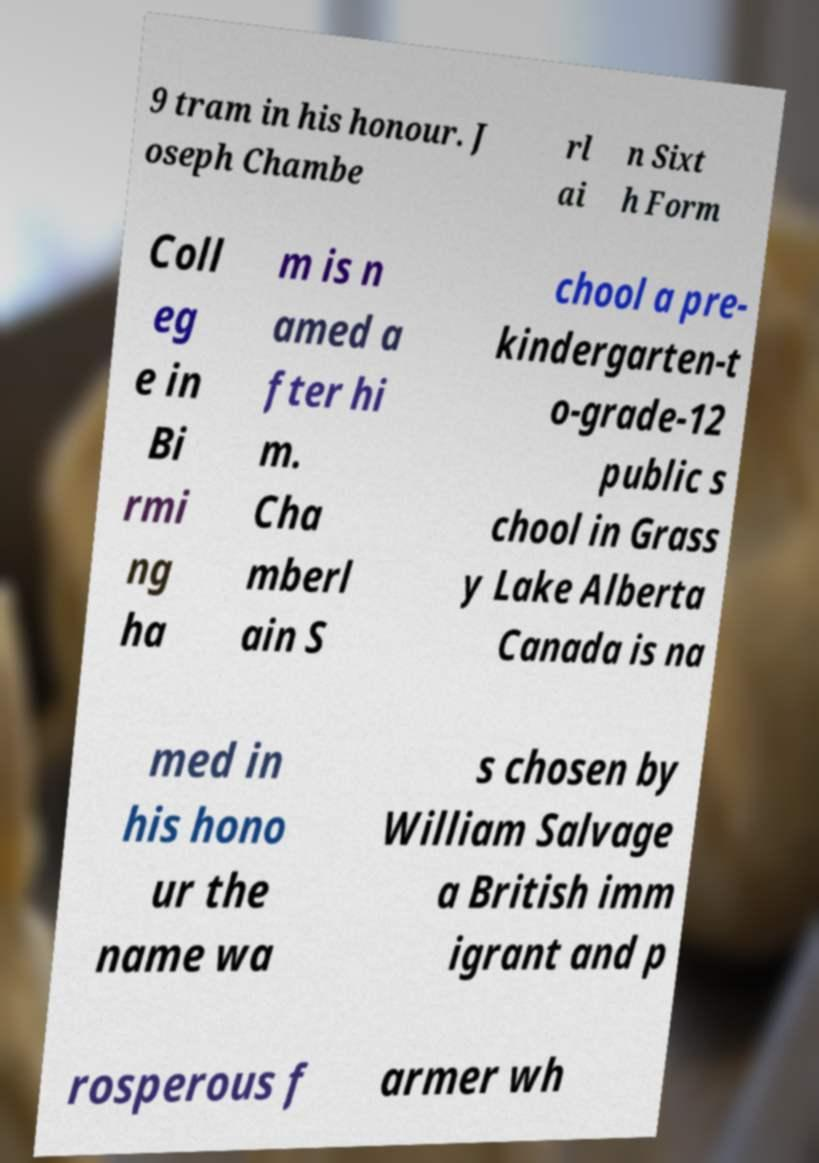What messages or text are displayed in this image? I need them in a readable, typed format. 9 tram in his honour. J oseph Chambe rl ai n Sixt h Form Coll eg e in Bi rmi ng ha m is n amed a fter hi m. Cha mberl ain S chool a pre- kindergarten-t o-grade-12 public s chool in Grass y Lake Alberta Canada is na med in his hono ur the name wa s chosen by William Salvage a British imm igrant and p rosperous f armer wh 